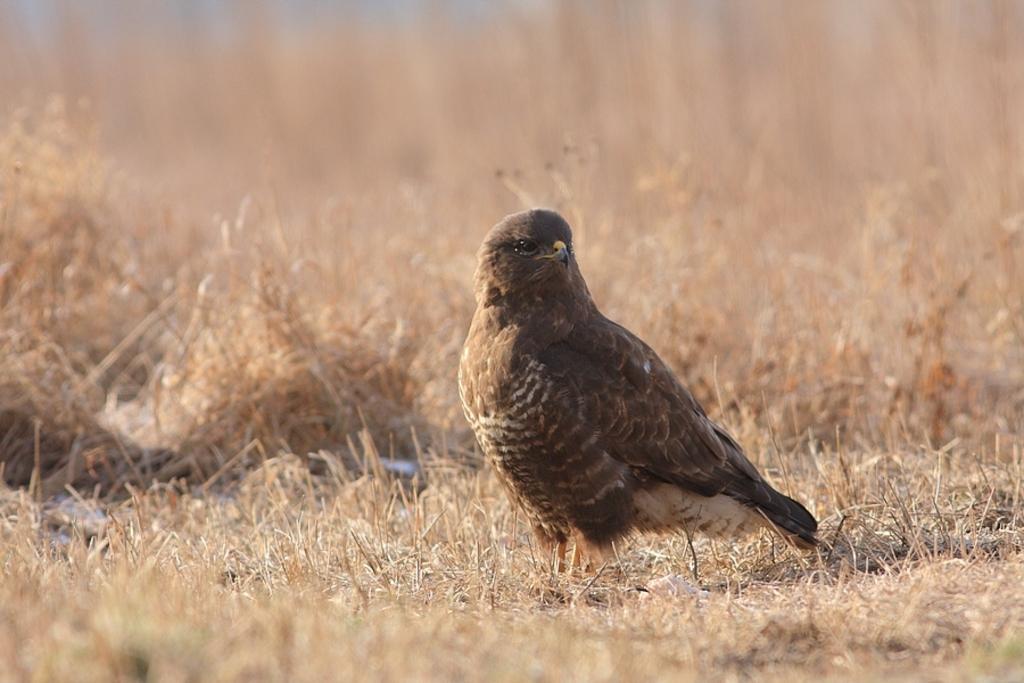Describe this image in one or two sentences. In this image there is a bird on the dried grass. 